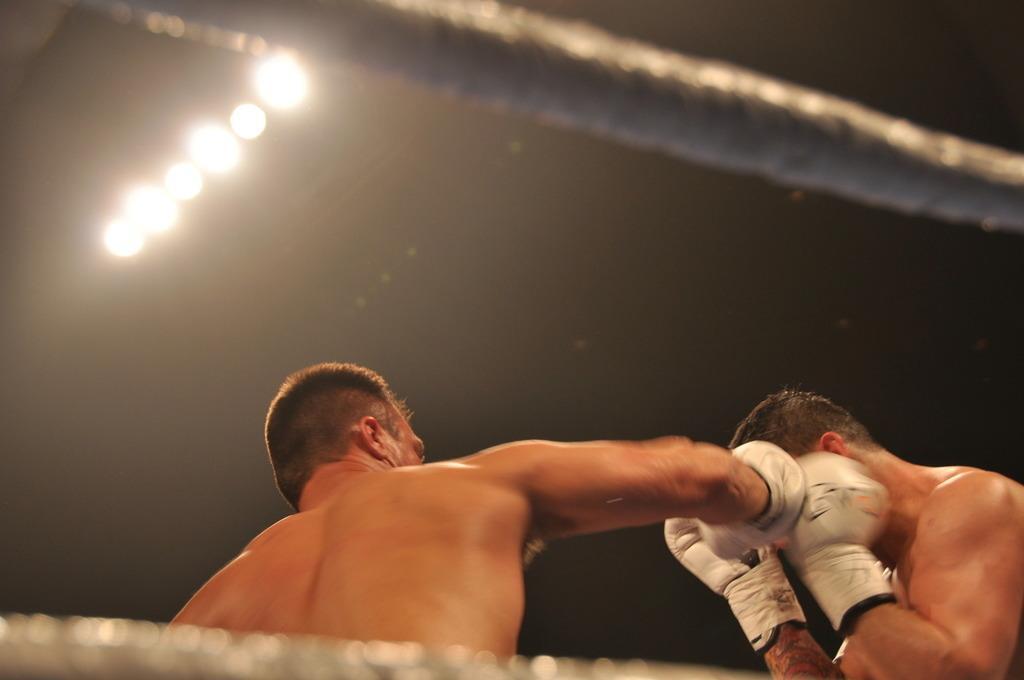In one or two sentences, can you explain what this image depicts? In this image we can see two persons wearing the hand gloves and boxing. We can also see the ropes and also the lights. 